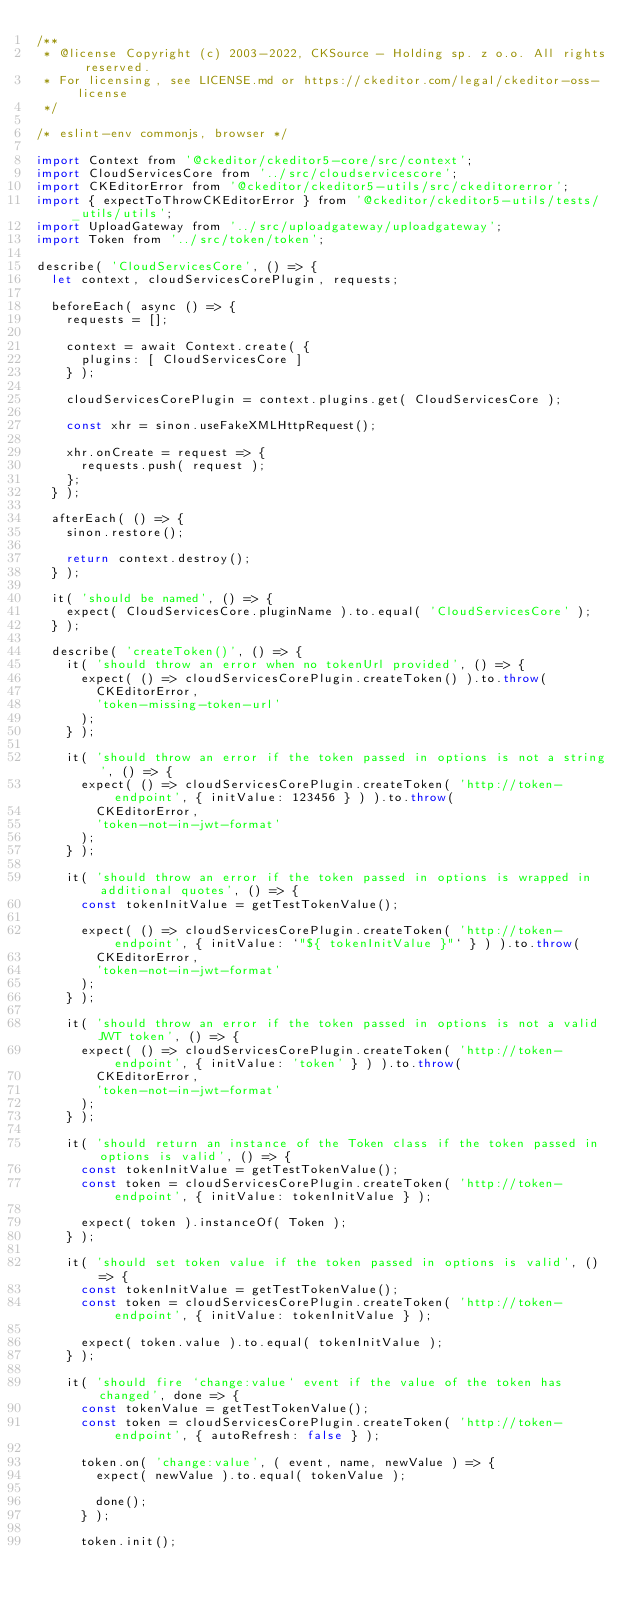Convert code to text. <code><loc_0><loc_0><loc_500><loc_500><_JavaScript_>/**
 * @license Copyright (c) 2003-2022, CKSource - Holding sp. z o.o. All rights reserved.
 * For licensing, see LICENSE.md or https://ckeditor.com/legal/ckeditor-oss-license
 */

/* eslint-env commonjs, browser */

import Context from '@ckeditor/ckeditor5-core/src/context';
import CloudServicesCore from '../src/cloudservicescore';
import CKEditorError from '@ckeditor/ckeditor5-utils/src/ckeditorerror';
import { expectToThrowCKEditorError } from '@ckeditor/ckeditor5-utils/tests/_utils/utils';
import UploadGateway from '../src/uploadgateway/uploadgateway';
import Token from '../src/token/token';

describe( 'CloudServicesCore', () => {
	let context, cloudServicesCorePlugin, requests;

	beforeEach( async () => {
		requests = [];

		context = await Context.create( {
			plugins: [ CloudServicesCore ]
		} );

		cloudServicesCorePlugin = context.plugins.get( CloudServicesCore );

		const xhr = sinon.useFakeXMLHttpRequest();

		xhr.onCreate = request => {
			requests.push( request );
		};
	} );

	afterEach( () => {
		sinon.restore();

		return context.destroy();
	} );

	it( 'should be named', () => {
		expect( CloudServicesCore.pluginName ).to.equal( 'CloudServicesCore' );
	} );

	describe( 'createToken()', () => {
		it( 'should throw an error when no tokenUrl provided', () => {
			expect( () => cloudServicesCorePlugin.createToken() ).to.throw(
				CKEditorError,
				'token-missing-token-url'
			);
		} );

		it( 'should throw an error if the token passed in options is not a string', () => {
			expect( () => cloudServicesCorePlugin.createToken( 'http://token-endpoint', { initValue: 123456 } ) ).to.throw(
				CKEditorError,
				'token-not-in-jwt-format'
			);
		} );

		it( 'should throw an error if the token passed in options is wrapped in additional quotes', () => {
			const tokenInitValue = getTestTokenValue();

			expect( () => cloudServicesCorePlugin.createToken( 'http://token-endpoint', { initValue: `"${ tokenInitValue }"` } ) ).to.throw(
				CKEditorError,
				'token-not-in-jwt-format'
			);
		} );

		it( 'should throw an error if the token passed in options is not a valid JWT token', () => {
			expect( () => cloudServicesCorePlugin.createToken( 'http://token-endpoint', { initValue: 'token' } ) ).to.throw(
				CKEditorError,
				'token-not-in-jwt-format'
			);
		} );

		it( 'should return an instance of the Token class if the token passed in options is valid', () => {
			const tokenInitValue = getTestTokenValue();
			const token = cloudServicesCorePlugin.createToken( 'http://token-endpoint', { initValue: tokenInitValue } );

			expect( token ).instanceOf( Token );
		} );

		it( 'should set token value if the token passed in options is valid', () => {
			const tokenInitValue = getTestTokenValue();
			const token = cloudServicesCorePlugin.createToken( 'http://token-endpoint', { initValue: tokenInitValue } );

			expect( token.value ).to.equal( tokenInitValue );
		} );

		it( 'should fire `change:value` event if the value of the token has changed', done => {
			const tokenValue = getTestTokenValue();
			const token = cloudServicesCorePlugin.createToken( 'http://token-endpoint', { autoRefresh: false } );

			token.on( 'change:value', ( event, name, newValue ) => {
				expect( newValue ).to.equal( tokenValue );

				done();
			} );

			token.init();
</code> 